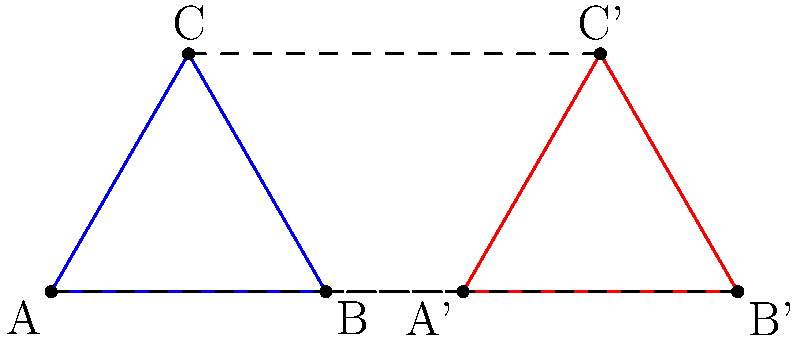Consider the two equilateral triangles ABC and A'B'C' shown in the figure. If we define a mapping f from the vertices of ABC to the vertices of A'B'C' such that f(A) = A', f(B) = B', and f(C) = C', could this mapping represent a group homomorphism between two groups? Explain your reasoning. To determine if this mapping could represent a group homomorphism, we need to consider the following steps:

1. Group structure: First, we need to identify the groups involved. The vertices of each triangle can be considered as elements of a group under rotation.

2. Group operation: The group operation for each triangle would be rotation by 120° (or 2π/3 radians) clockwise around the center of the triangle.

3. Homomorphism property: For a mapping to be a group homomorphism, it must preserve the group operation. In other words, for elements a and b in the first group, f(a * b) = f(a) * f(b), where * represents the group operation.

4. Checking the property:
   - Let's consider rotating ABC by 120° clockwise: A → B → C → A
   - The corresponding rotation in A'B'C' would be: A' → B' → C' → A'
   
5. Preservation of structure:
   - f(A * B) = f(C) = C'
   - f(A) * f(B) = A' * B' = C'

6. Conclusion: We can see that the mapping preserves the group operation of rotation. This holds true for all combinations of vertices.

Therefore, this mapping could indeed represent a group homomorphism between the rotational groups of the two triangles.
Answer: Yes, the mapping could represent a group homomorphism. 